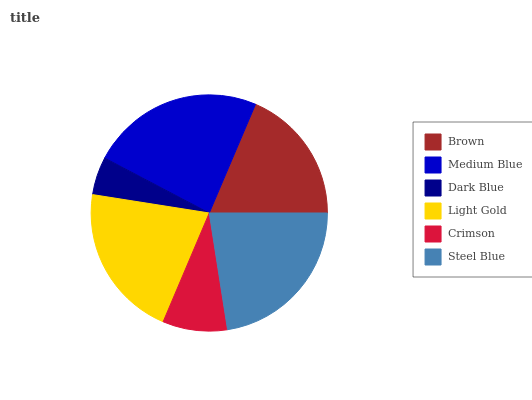Is Dark Blue the minimum?
Answer yes or no. Yes. Is Medium Blue the maximum?
Answer yes or no. Yes. Is Medium Blue the minimum?
Answer yes or no. No. Is Dark Blue the maximum?
Answer yes or no. No. Is Medium Blue greater than Dark Blue?
Answer yes or no. Yes. Is Dark Blue less than Medium Blue?
Answer yes or no. Yes. Is Dark Blue greater than Medium Blue?
Answer yes or no. No. Is Medium Blue less than Dark Blue?
Answer yes or no. No. Is Light Gold the high median?
Answer yes or no. Yes. Is Brown the low median?
Answer yes or no. Yes. Is Steel Blue the high median?
Answer yes or no. No. Is Steel Blue the low median?
Answer yes or no. No. 